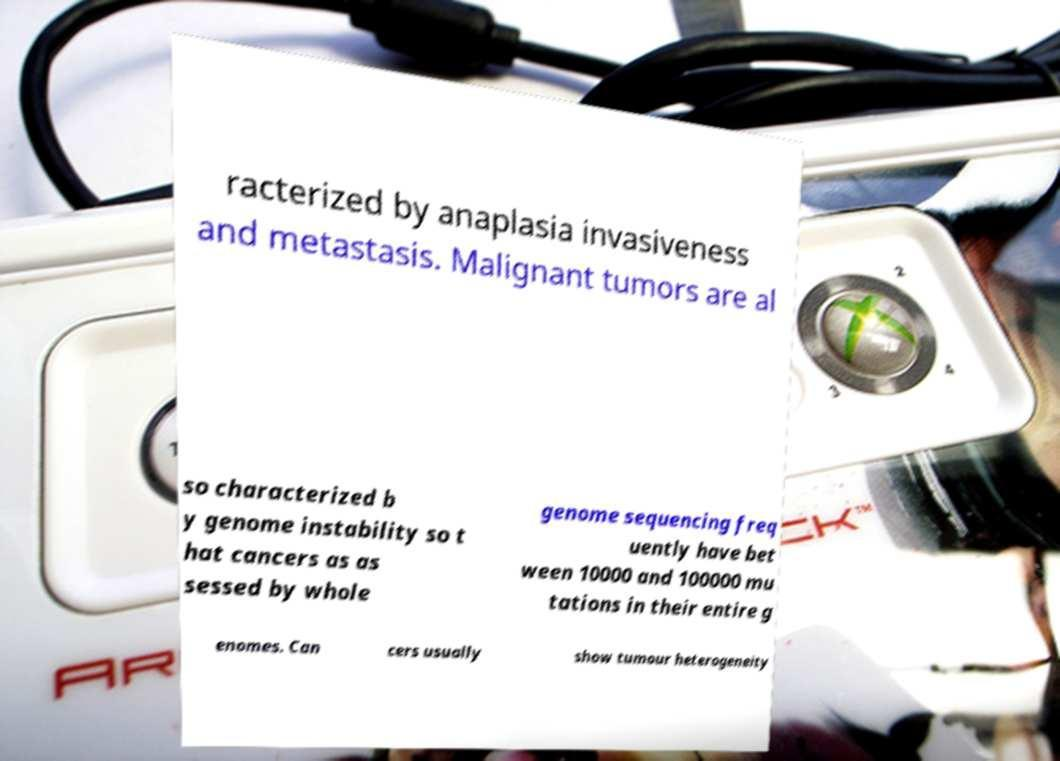Could you assist in decoding the text presented in this image and type it out clearly? racterized by anaplasia invasiveness and metastasis. Malignant tumors are al so characterized b y genome instability so t hat cancers as as sessed by whole genome sequencing freq uently have bet ween 10000 and 100000 mu tations in their entire g enomes. Can cers usually show tumour heterogeneity 